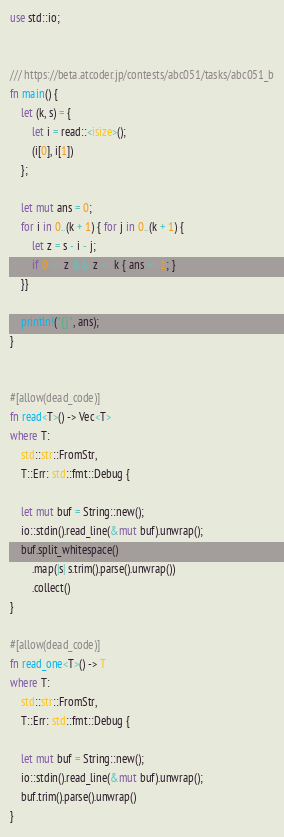Convert code to text. <code><loc_0><loc_0><loc_500><loc_500><_Rust_>use std::io;


/// https://beta.atcoder.jp/contests/abc051/tasks/abc051_b
fn main() {
    let (k, s) = {
        let i = read::<isize>();
        (i[0], i[1])
    };

    let mut ans = 0;
    for i in 0..(k + 1) { for j in 0..(k + 1) {
        let z = s - i - j;
        if 0 <= z && z <= k { ans += 1; }
    }}

    println!("{}", ans);
}


#[allow(dead_code)]
fn read<T>() -> Vec<T>
where T:
    std::str::FromStr,
    T::Err: std::fmt::Debug {

    let mut buf = String::new();
    io::stdin().read_line(&mut buf).unwrap();
    buf.split_whitespace()
        .map(|s| s.trim().parse().unwrap())
        .collect()
}

#[allow(dead_code)]
fn read_one<T>() -> T
where T:
    std::str::FromStr,
    T::Err: std::fmt::Debug {

    let mut buf = String::new();
    io::stdin().read_line(&mut buf).unwrap();
    buf.trim().parse().unwrap()
}</code> 